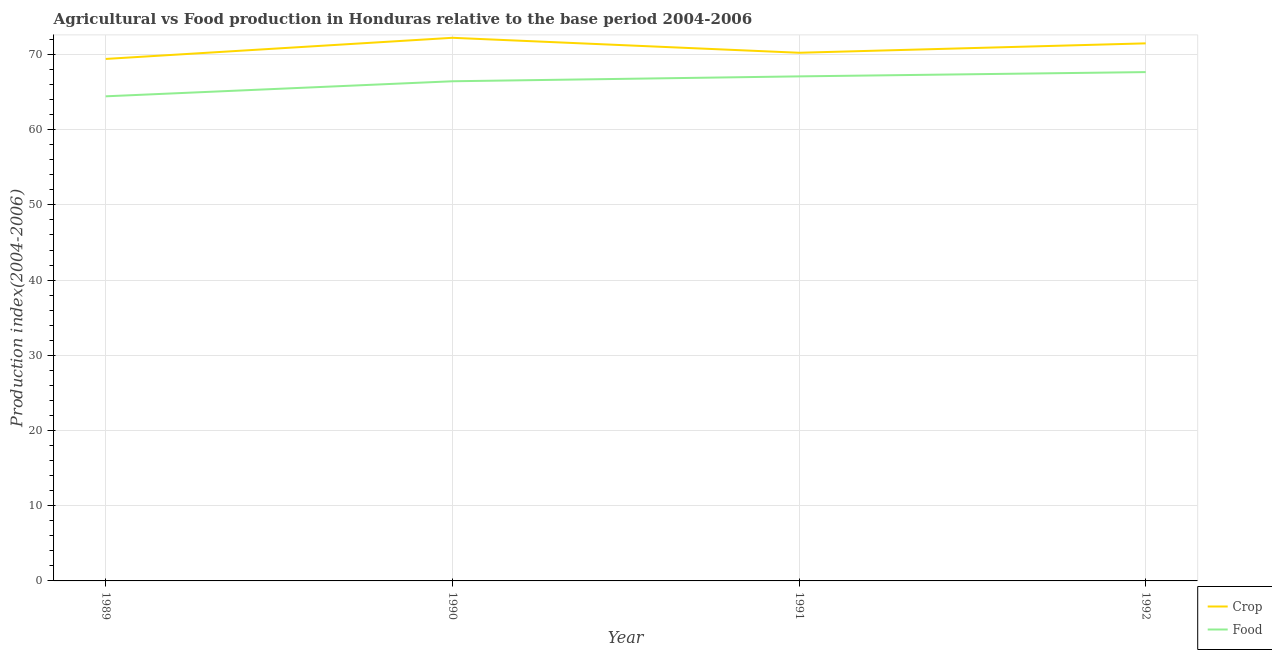How many different coloured lines are there?
Make the answer very short. 2. Does the line corresponding to food production index intersect with the line corresponding to crop production index?
Make the answer very short. No. What is the food production index in 1989?
Your response must be concise. 64.44. Across all years, what is the maximum crop production index?
Give a very brief answer. 72.22. Across all years, what is the minimum crop production index?
Give a very brief answer. 69.41. What is the total food production index in the graph?
Make the answer very short. 265.63. What is the difference between the crop production index in 1989 and that in 1991?
Your response must be concise. -0.82. What is the difference between the crop production index in 1991 and the food production index in 1992?
Give a very brief answer. 2.57. What is the average food production index per year?
Offer a very short reply. 66.41. In the year 1991, what is the difference between the crop production index and food production index?
Give a very brief answer. 3.14. What is the ratio of the crop production index in 1990 to that in 1991?
Your answer should be compact. 1.03. What is the difference between the highest and the second highest food production index?
Your answer should be very brief. 0.57. What is the difference between the highest and the lowest crop production index?
Give a very brief answer. 2.81. In how many years, is the food production index greater than the average food production index taken over all years?
Your answer should be very brief. 3. Does the food production index monotonically increase over the years?
Provide a short and direct response. Yes. Is the crop production index strictly greater than the food production index over the years?
Your answer should be compact. Yes. Is the food production index strictly less than the crop production index over the years?
Ensure brevity in your answer.  Yes. How many years are there in the graph?
Provide a succinct answer. 4. Are the values on the major ticks of Y-axis written in scientific E-notation?
Ensure brevity in your answer.  No. Does the graph contain grids?
Keep it short and to the point. Yes. Where does the legend appear in the graph?
Ensure brevity in your answer.  Bottom right. How many legend labels are there?
Give a very brief answer. 2. What is the title of the graph?
Your response must be concise. Agricultural vs Food production in Honduras relative to the base period 2004-2006. What is the label or title of the X-axis?
Make the answer very short. Year. What is the label or title of the Y-axis?
Ensure brevity in your answer.  Production index(2004-2006). What is the Production index(2004-2006) in Crop in 1989?
Your response must be concise. 69.41. What is the Production index(2004-2006) in Food in 1989?
Offer a very short reply. 64.44. What is the Production index(2004-2006) of Crop in 1990?
Ensure brevity in your answer.  72.22. What is the Production index(2004-2006) in Food in 1990?
Provide a succinct answer. 66.44. What is the Production index(2004-2006) of Crop in 1991?
Give a very brief answer. 70.23. What is the Production index(2004-2006) in Food in 1991?
Your answer should be very brief. 67.09. What is the Production index(2004-2006) of Crop in 1992?
Offer a very short reply. 71.48. What is the Production index(2004-2006) of Food in 1992?
Ensure brevity in your answer.  67.66. Across all years, what is the maximum Production index(2004-2006) of Crop?
Provide a succinct answer. 72.22. Across all years, what is the maximum Production index(2004-2006) in Food?
Your answer should be compact. 67.66. Across all years, what is the minimum Production index(2004-2006) of Crop?
Your answer should be very brief. 69.41. Across all years, what is the minimum Production index(2004-2006) in Food?
Offer a very short reply. 64.44. What is the total Production index(2004-2006) in Crop in the graph?
Give a very brief answer. 283.34. What is the total Production index(2004-2006) of Food in the graph?
Offer a terse response. 265.63. What is the difference between the Production index(2004-2006) in Crop in 1989 and that in 1990?
Your response must be concise. -2.81. What is the difference between the Production index(2004-2006) in Crop in 1989 and that in 1991?
Provide a succinct answer. -0.82. What is the difference between the Production index(2004-2006) in Food in 1989 and that in 1991?
Offer a terse response. -2.65. What is the difference between the Production index(2004-2006) of Crop in 1989 and that in 1992?
Your answer should be very brief. -2.07. What is the difference between the Production index(2004-2006) in Food in 1989 and that in 1992?
Offer a very short reply. -3.22. What is the difference between the Production index(2004-2006) of Crop in 1990 and that in 1991?
Offer a very short reply. 1.99. What is the difference between the Production index(2004-2006) of Food in 1990 and that in 1991?
Give a very brief answer. -0.65. What is the difference between the Production index(2004-2006) of Crop in 1990 and that in 1992?
Provide a succinct answer. 0.74. What is the difference between the Production index(2004-2006) of Food in 1990 and that in 1992?
Keep it short and to the point. -1.22. What is the difference between the Production index(2004-2006) of Crop in 1991 and that in 1992?
Ensure brevity in your answer.  -1.25. What is the difference between the Production index(2004-2006) of Food in 1991 and that in 1992?
Your response must be concise. -0.57. What is the difference between the Production index(2004-2006) in Crop in 1989 and the Production index(2004-2006) in Food in 1990?
Provide a short and direct response. 2.97. What is the difference between the Production index(2004-2006) in Crop in 1989 and the Production index(2004-2006) in Food in 1991?
Offer a terse response. 2.32. What is the difference between the Production index(2004-2006) of Crop in 1990 and the Production index(2004-2006) of Food in 1991?
Give a very brief answer. 5.13. What is the difference between the Production index(2004-2006) of Crop in 1990 and the Production index(2004-2006) of Food in 1992?
Your answer should be very brief. 4.56. What is the difference between the Production index(2004-2006) in Crop in 1991 and the Production index(2004-2006) in Food in 1992?
Provide a succinct answer. 2.57. What is the average Production index(2004-2006) of Crop per year?
Offer a terse response. 70.83. What is the average Production index(2004-2006) of Food per year?
Offer a very short reply. 66.41. In the year 1989, what is the difference between the Production index(2004-2006) of Crop and Production index(2004-2006) of Food?
Ensure brevity in your answer.  4.97. In the year 1990, what is the difference between the Production index(2004-2006) in Crop and Production index(2004-2006) in Food?
Ensure brevity in your answer.  5.78. In the year 1991, what is the difference between the Production index(2004-2006) of Crop and Production index(2004-2006) of Food?
Provide a succinct answer. 3.14. In the year 1992, what is the difference between the Production index(2004-2006) in Crop and Production index(2004-2006) in Food?
Keep it short and to the point. 3.82. What is the ratio of the Production index(2004-2006) in Crop in 1989 to that in 1990?
Provide a short and direct response. 0.96. What is the ratio of the Production index(2004-2006) in Food in 1989 to that in 1990?
Your answer should be compact. 0.97. What is the ratio of the Production index(2004-2006) of Crop in 1989 to that in 1991?
Your response must be concise. 0.99. What is the ratio of the Production index(2004-2006) in Food in 1989 to that in 1991?
Offer a very short reply. 0.96. What is the ratio of the Production index(2004-2006) in Crop in 1989 to that in 1992?
Ensure brevity in your answer.  0.97. What is the ratio of the Production index(2004-2006) in Crop in 1990 to that in 1991?
Your answer should be compact. 1.03. What is the ratio of the Production index(2004-2006) of Food in 1990 to that in 1991?
Provide a short and direct response. 0.99. What is the ratio of the Production index(2004-2006) in Crop in 1990 to that in 1992?
Offer a very short reply. 1.01. What is the ratio of the Production index(2004-2006) of Food in 1990 to that in 1992?
Give a very brief answer. 0.98. What is the ratio of the Production index(2004-2006) in Crop in 1991 to that in 1992?
Your answer should be compact. 0.98. What is the difference between the highest and the second highest Production index(2004-2006) of Crop?
Provide a succinct answer. 0.74. What is the difference between the highest and the second highest Production index(2004-2006) of Food?
Give a very brief answer. 0.57. What is the difference between the highest and the lowest Production index(2004-2006) of Crop?
Offer a terse response. 2.81. What is the difference between the highest and the lowest Production index(2004-2006) of Food?
Provide a succinct answer. 3.22. 